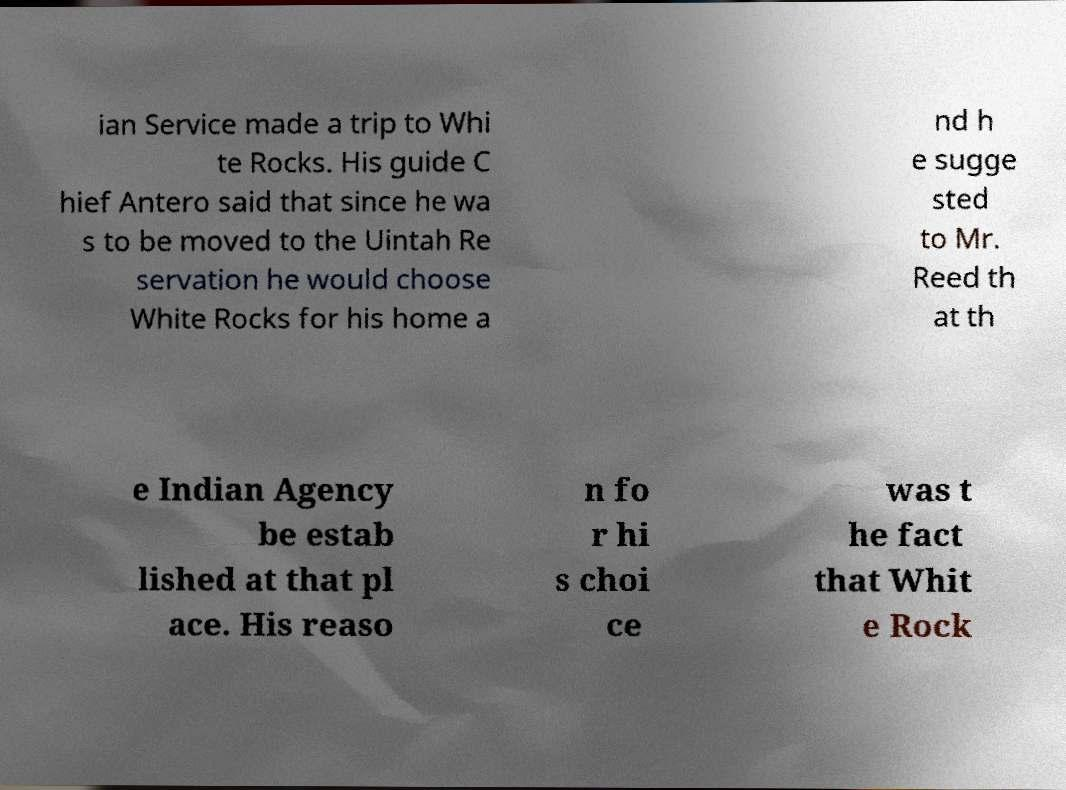Can you accurately transcribe the text from the provided image for me? ian Service made a trip to Whi te Rocks. His guide C hief Antero said that since he wa s to be moved to the Uintah Re servation he would choose White Rocks for his home a nd h e sugge sted to Mr. Reed th at th e Indian Agency be estab lished at that pl ace. His reaso n fo r hi s choi ce was t he fact that Whit e Rock 